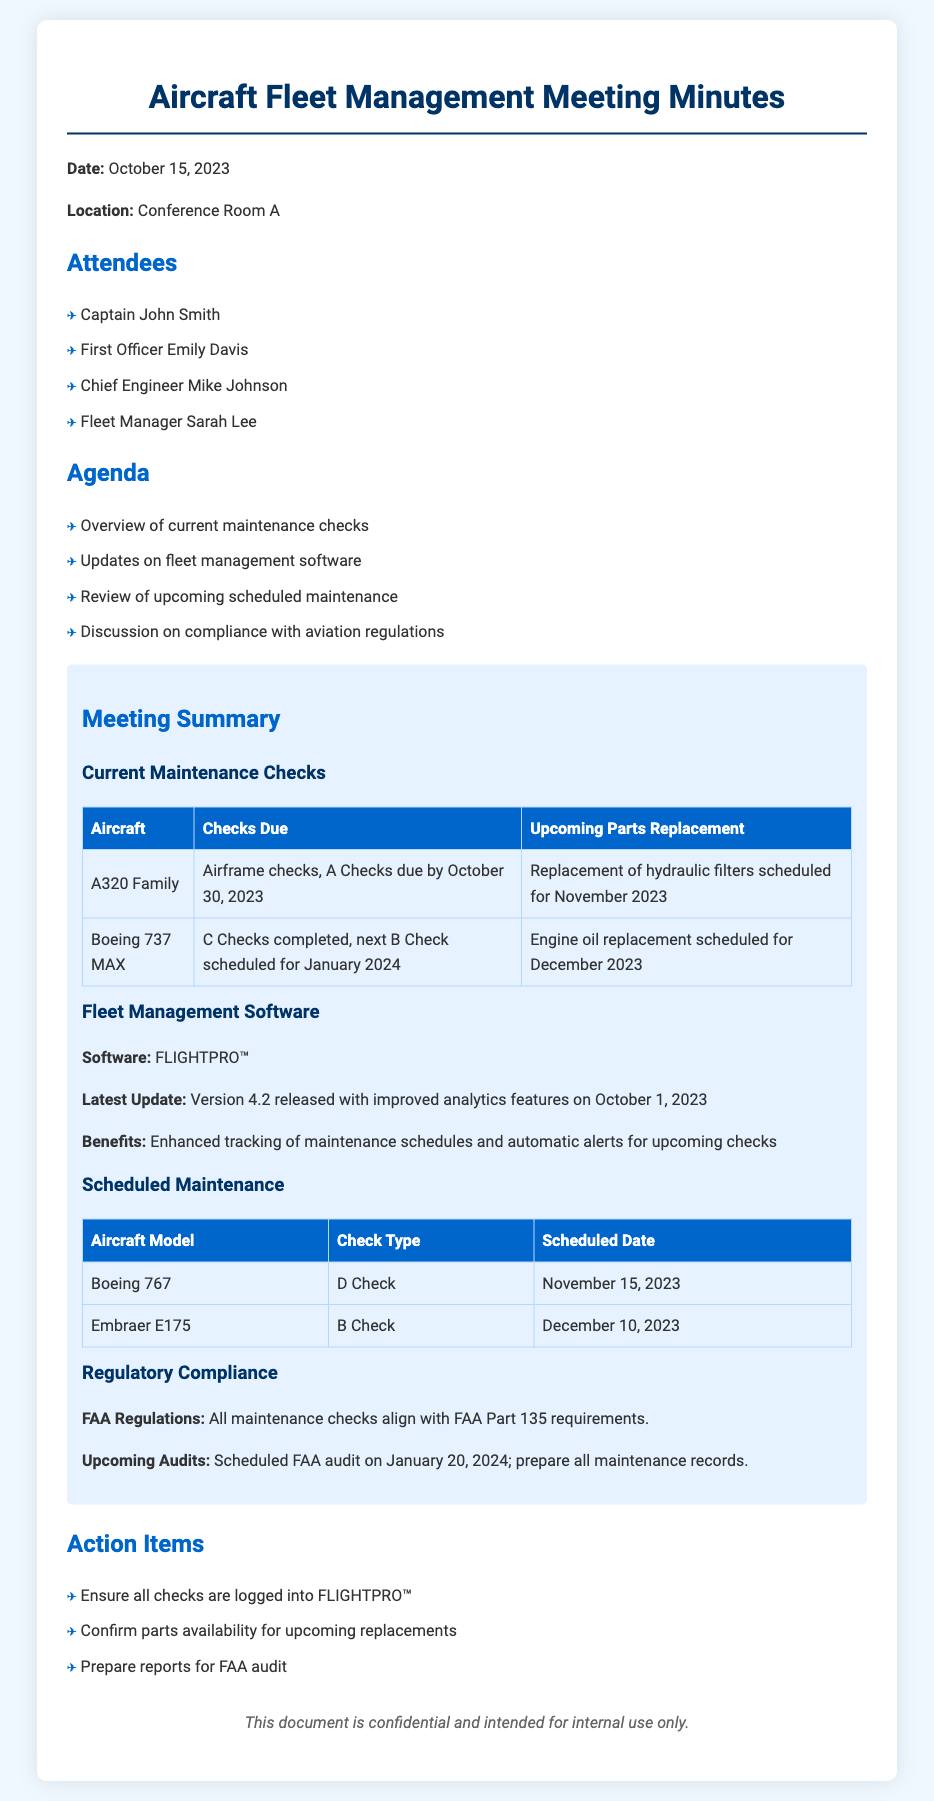what is the date of the meeting? The date of the meeting is mentioned in the document header.
Answer: October 15, 2023 who is the Fleet Manager? The document lists the attendees and their roles.
Answer: Sarah Lee what is the next B Check scheduled for the Boeing 737 MAX? This information is provided in the Current Maintenance Checks section.
Answer: January 2024 what aircraft model is scheduled for a D Check on November 15, 2023? The Scheduled Maintenance table specifies the aircraft model and the date of the D Check.
Answer: Boeing 767 what software version was released on October 1, 2023? The document discusses updates to the fleet management software and the release date.
Answer: Version 4.2 how many action items are listed at the end of the document? The action items section counts the distinct items related to responsibilities after the meeting.
Answer: Three what type of regulatory compliance is mentioned? The meeting minutes provide details regarding compliance with regulations in a specific section.
Answer: FAA Part 135 when is the scheduled FAA audit? The document states the date for the upcoming FAA audit related to maintenance records.
Answer: January 20, 2024 